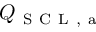Convert formula to latex. <formula><loc_0><loc_0><loc_500><loc_500>Q _ { S C L , a }</formula> 